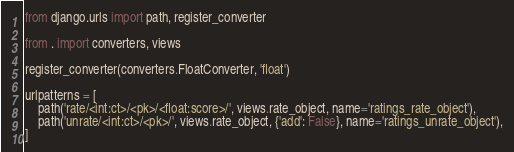<code> <loc_0><loc_0><loc_500><loc_500><_Python_>from django.urls import path, register_converter

from . import converters, views

register_converter(converters.FloatConverter, 'float')

urlpatterns = [
    path('rate/<int:ct>/<pk>/<float:score>/', views.rate_object, name='ratings_rate_object'),
    path('unrate/<int:ct>/<pk>/', views.rate_object, {'add': False}, name='ratings_unrate_object'),
]
</code> 